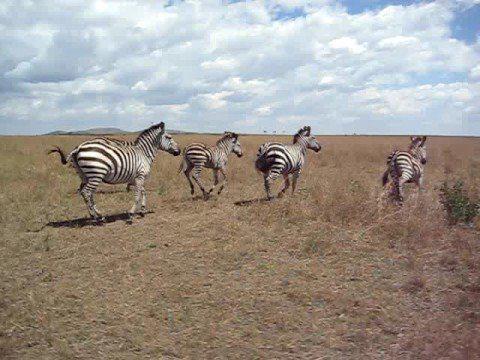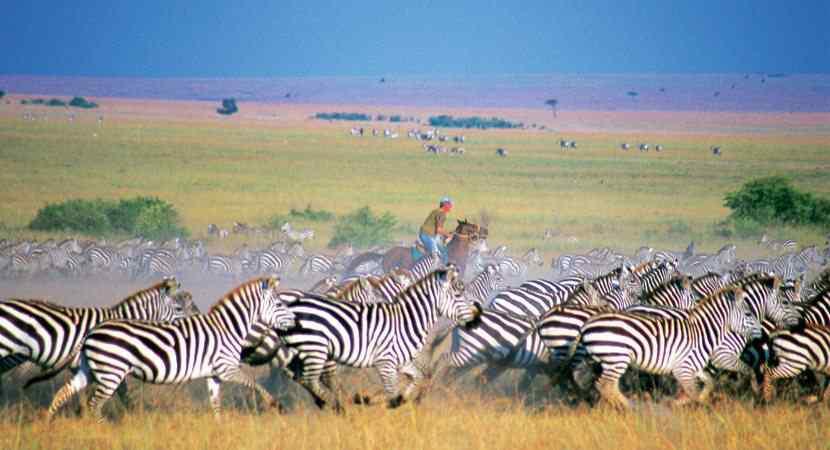The first image is the image on the left, the second image is the image on the right. Evaluate the accuracy of this statement regarding the images: "Nine or fewer zebras are present.". Is it true? Answer yes or no. No. The first image is the image on the left, the second image is the image on the right. For the images displayed, is the sentence "All the zebras are running." factually correct? Answer yes or no. Yes. 